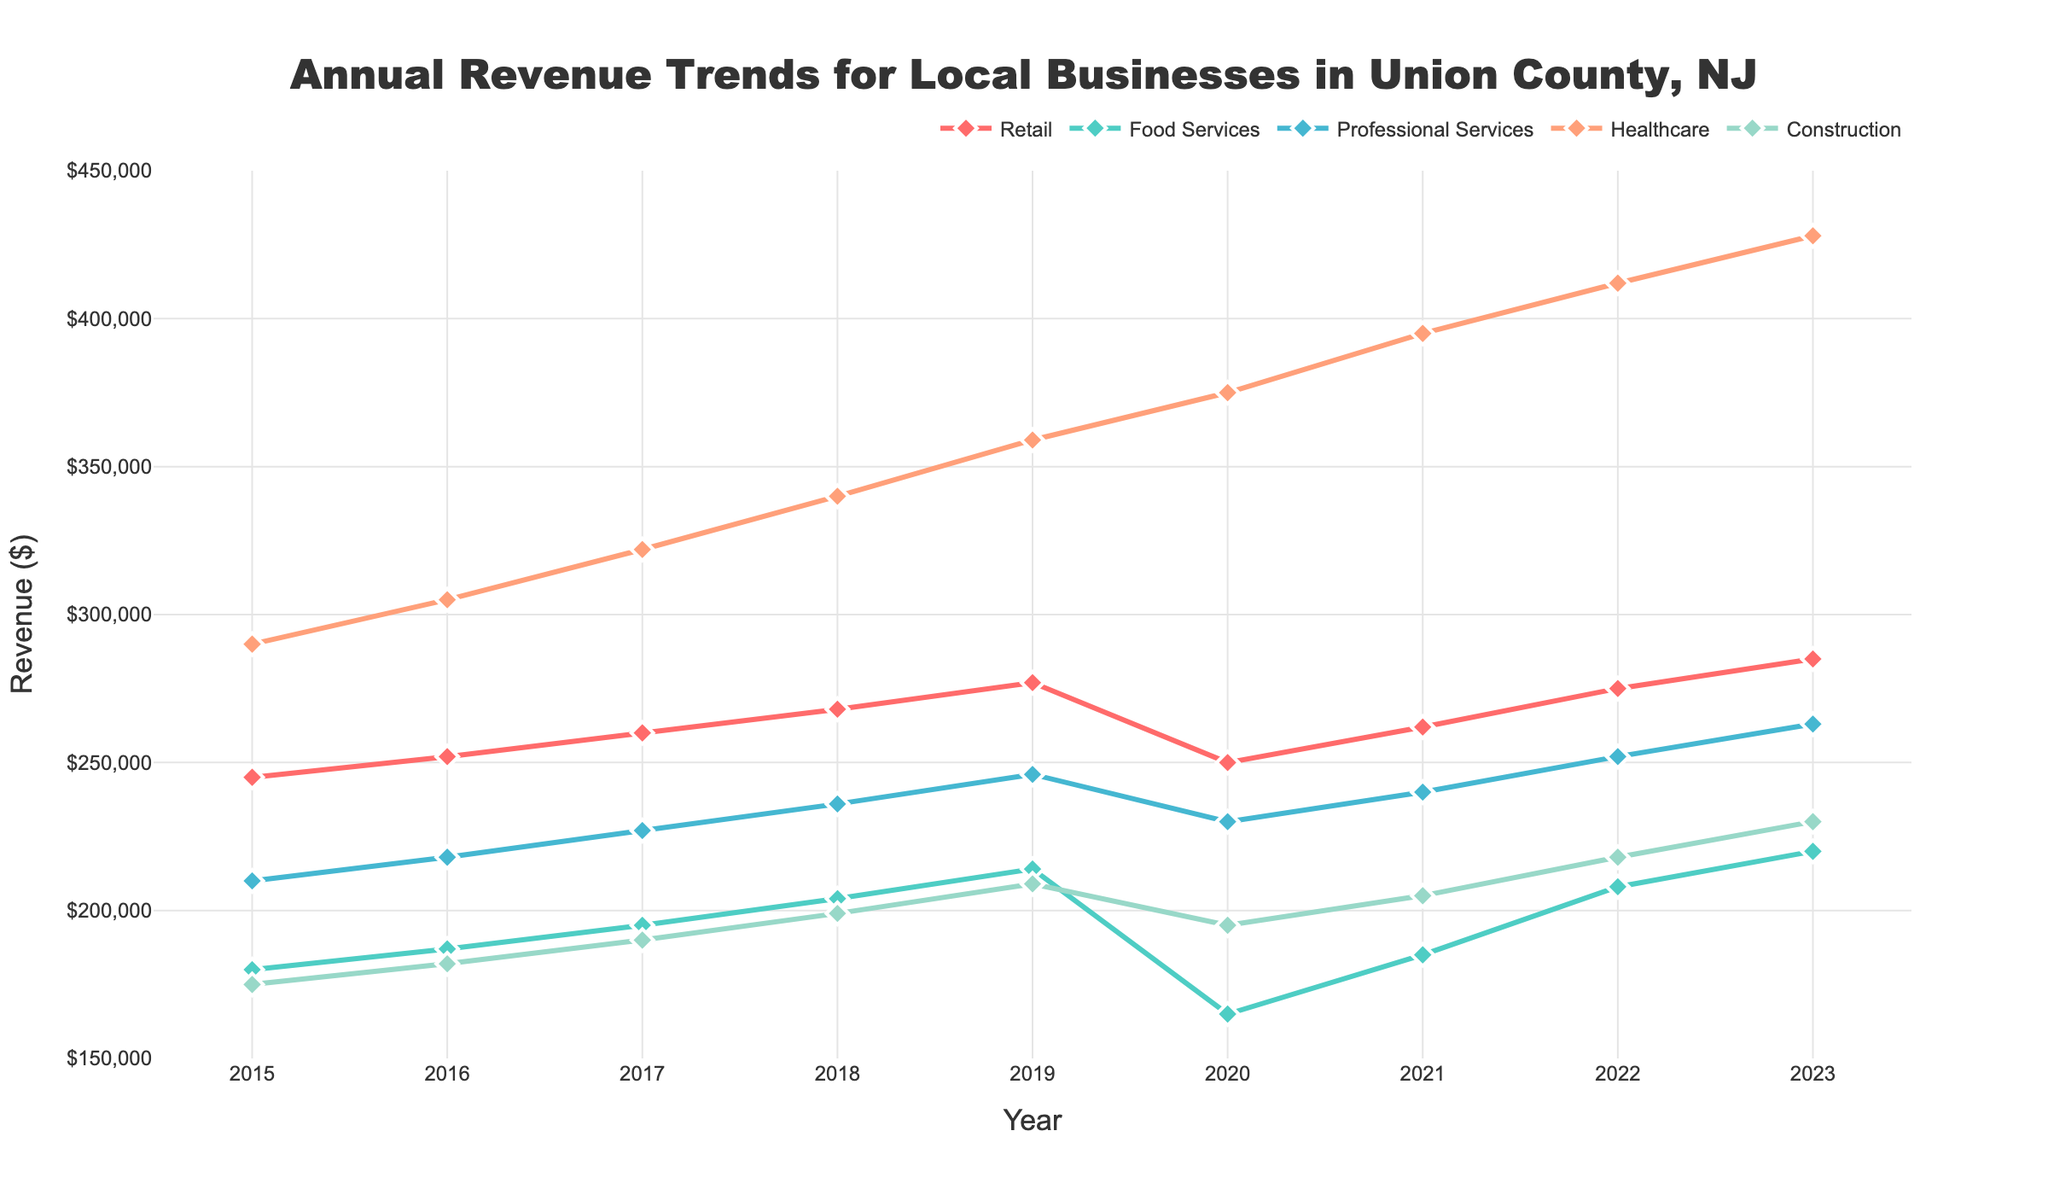what industry had the highest revenue in 2023? The highest revenue in 2023 is represented by the tallest line on the graph. Checking the lines, we see that the Healthcare sector has the highest point.
Answer: Healthcare which industry saw the largest increase in revenue from 2015 to 2023? The largest increase is found by looking at the difference between the 2023 and 2015 values for each industry. Healthcare went from $290,000 to $428,000, an increase of $138,000, which is the largest.
Answer: Healthcare how did the revenue of the Food Services industry change between 2019 and 2020? To determine the change, subtract the 2020 value from the 2019 value for Food Services, which is $165,000 - $214,000. This gives a decrease of $49,000.
Answer: Decreased by $49,000 which two industries had similar revenue trends from 2015 to 2023? Comparing the lines on the chart, Retail and Professional Services show similar upward trends with no sharp declines, unlike other industries.
Answer: Retail and Professional Services what was the average revenue of the Construction industry over the years? Sum the Construction revenues from each year then divide by the number of years. ($175,000 + $182,000 + $190,000 + $199,000 + $209,000 + $195,000 + $205,000 + $218,000 + $230,000) / 9 = $200,333.33
Answer: $200,333.33 how did the Professional Services industry perform during 2020 compared to 2022? Checking the graph, in 2020, Professional Services had $230,000 and increased to $252,000 in 2022, showing an increase.
Answer: Increased by $22,000 which two years saw a decrease in revenue for the Retail industry? The graph shows Retail had a decrease only once, from 2019 ($277,000) to 2020 ($250,000). Thus only one year had a decrease, 2020.
Answer: 2020 how much higher was Healthcare revenue in 2023 compared to Professional Services? Subtract Professional Services revenue in 2023 ($263,000) from Healthcare revenue in 2023 ($428,000). $428,000 - $263,000 = $165,000.
Answer: $165,000 what is the overall trend for Food Services from 2015 to 2023? Observing the line for Food Services, it shows an incremental increase till 2019 ($214,000), a significant dip in 2020 ($165,000), then gradual recovery.
Answer: Generally increasing with a dip in 2020 which year had the smallest gap between Retail and Construction revenues? The gap is calculated by subtraction; inspecting visually or calculating each year, the smallest difference was in 2016 with $252,000 - $182,000 = $70,000.
Answer: 2016 